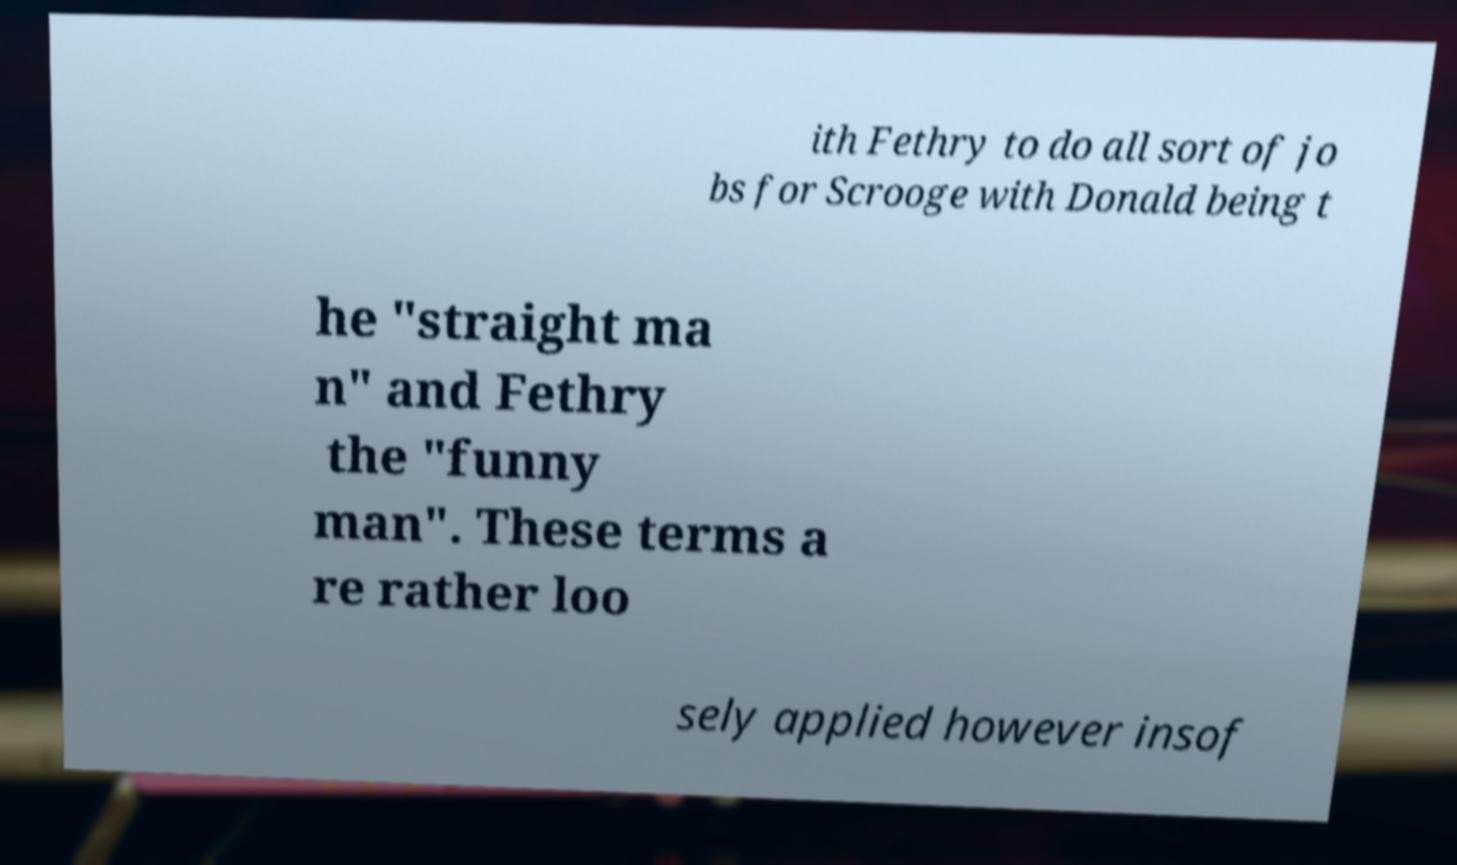There's text embedded in this image that I need extracted. Can you transcribe it verbatim? ith Fethry to do all sort of jo bs for Scrooge with Donald being t he "straight ma n" and Fethry the "funny man". These terms a re rather loo sely applied however insof 